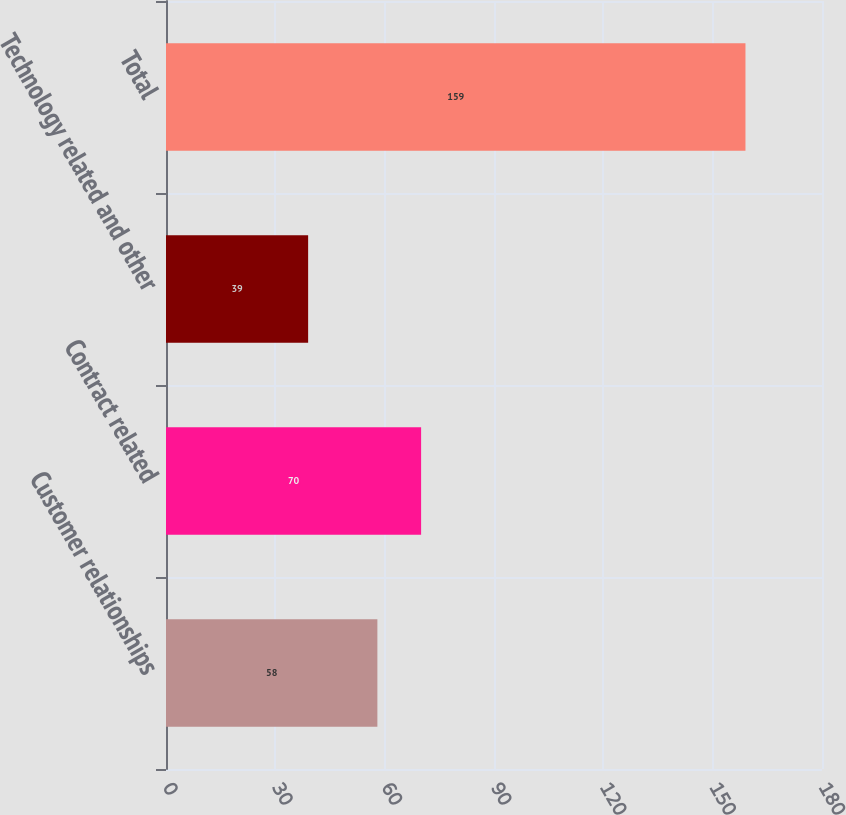<chart> <loc_0><loc_0><loc_500><loc_500><bar_chart><fcel>Customer relationships<fcel>Contract related<fcel>Technology related and other<fcel>Total<nl><fcel>58<fcel>70<fcel>39<fcel>159<nl></chart> 